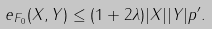Convert formula to latex. <formula><loc_0><loc_0><loc_500><loc_500>& e _ { F _ { 0 } } ( X , Y ) \leq ( 1 + 2 \lambda ) | X | | Y | p ^ { \prime } .</formula> 